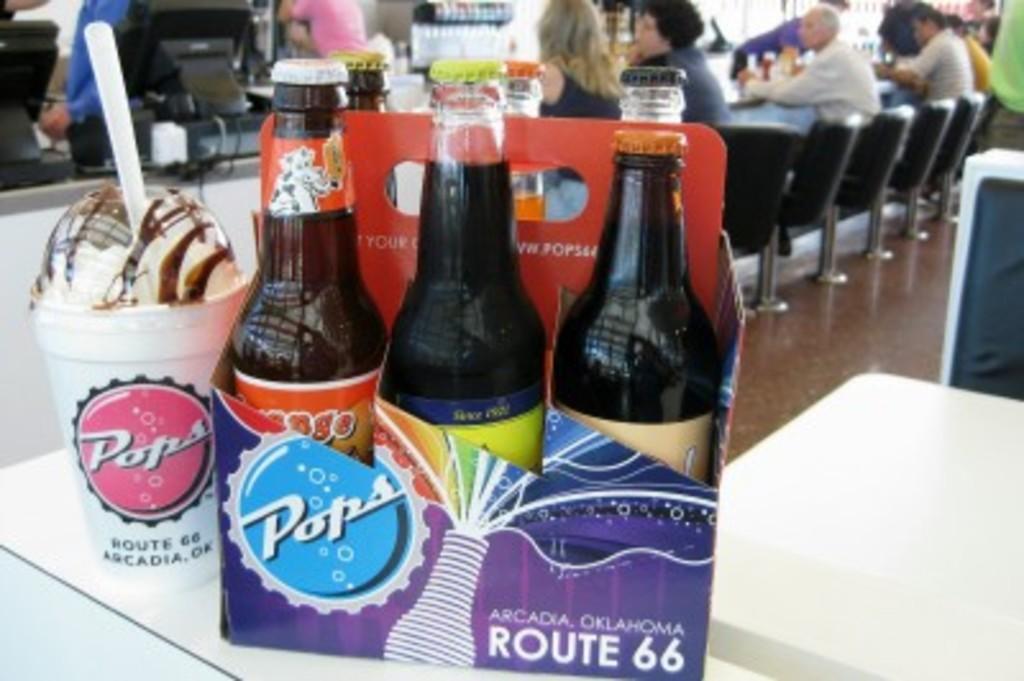Describe this image in one or two sentences. This picture shows a pack of three bottles on the table. Beside, there is a cup with some drink here and a straw inserted in it. In the background, there are some people sitting in the chairs in front of a desk. There is a monitor here. 